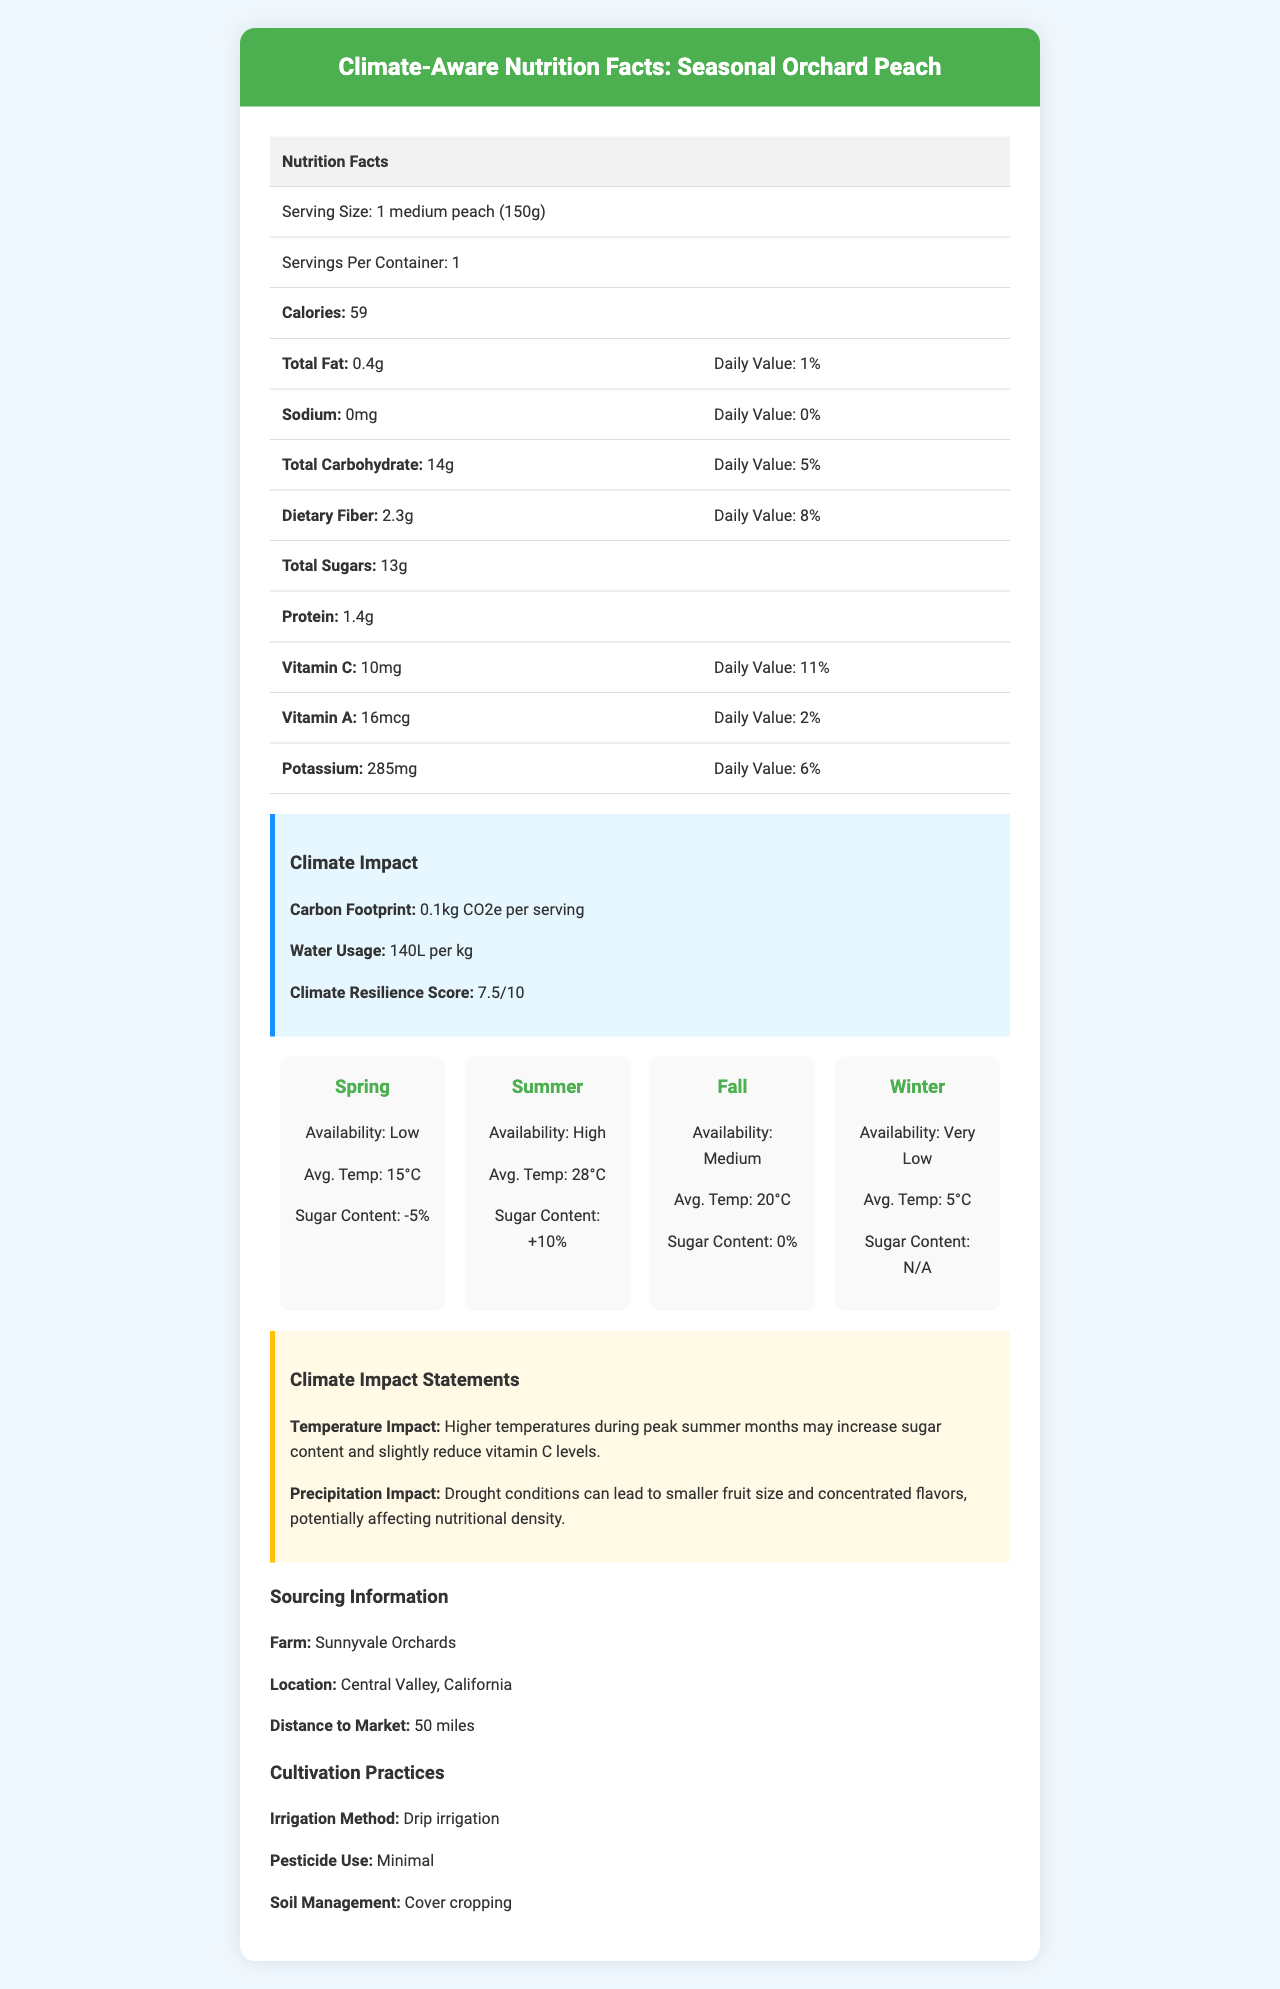What is the serving size for a Seasonal Orchard Peach? The serving size is specified as 1 medium peach, weighing 150 grams, in the document.
Answer: 1 medium peach (150g) How many calories are in one serving of the Seasonal Orchard Peach? The calories content is mentioned as 59 per serving in the nutritional information table.
Answer: 59 What is the daily value percentage of Vitamin C? The daily value for Vitamin C is listed as 11% in the nutrition facts section.
Answer: 11% Which season has the highest availability of Seasonal Orchard Peaches? The document indicates that the availability of peaches is highest during the summer.
Answer: Summer What is the potassium content in a serving of Seasonal Orchard Peach? The potassium content is listed as 285mg per serving in the nutritional information.
Answer: 285mg Which season shows a +10% sugar content variation? 
A. Spring 
B. Summer 
C. Fall 
D. Winter The summer season is noted to have a +10% sugar content variation.
Answer: B. Summer What is the Climate Resilience Score of the Seasonal Orchard Peach? 
1. 5.0 
2. 6.5 
3. 7.5 
4. 8.5 The Climate Resilience Score is 7.5, as listed under climate impact information.
Answer: 3. 7.5 Does the peach contain any sodium? The sodium content is mentioned as 0mg, indicating there is no sodium in the peach.
Answer: No What is the average temperature during the fall season? The document states that the average temperature during fall is 20°C.
Answer: 20°C Describe the main information provided in the document. The document details the nutritional content of a Seasonal Orchard Peach, such as calories, fats, vitamins, and minerals. It also covers climate impact metrics like carbon footprint and water usage, describes seasonal variations in sugar content and availability, and includes sourcing and cultivation practices. There is also information on the climate resilience score and statements on how temperature and precipitation affect the peach's nutritional components.
Answer: The document provides a comprehensive overview of the nutritional facts and climate impact of the Seasonal Orchard Peach, including its serving size, calories, macronutrient and micronutrient content, seasonal variations in availability and sugar content, sourcing information, cultivation practices, climate resilience score, and the impact of temperature and precipitation on its nutritional density. How much water is used per kilogram for producing these peaches? The water usage is specified as 140 liters per kilogram in the climate impact section.
Answer: 140L per kg Which farm sources the Seasonal Orchard Peach? The sourcing information section lists Sunnyvale Orchards as the farm that provides the peach.
Answer: Sunnyvale Orchards What is the carbon footprint per serving for the Seasonal Orchard Peach? The carbon footprint is indicated to be 0.1kg CO2e per serving.
Answer: 0.1kg CO2e per serving Can the irrigation method of Sunnyvale Orchards be determined from the document? The document specifies the irrigation method as drip irrigation under cultivation practices.
Answer: Yes What is the impact of higher temperatures on the peach during summer? The temperature impact statement explains that higher temperatures can lead to increased sugar content and a slight reduction in vitamin C levels.
Answer: Higher temperatures during peak summer months may increase sugar content and slightly reduce vitamin C levels. Does the peach contain any added sugars? The document mentions total sugars but does not specify whether these sugars are naturally occurring or added.
Answer: Cannot be determined What are the two main cultivation practices used for these peaches besides drip irrigation? The cultivation practices section lists minimal pesticide use and cover cropping as the two additional practices.
Answer: Minimal pesticide use and cover cropping 